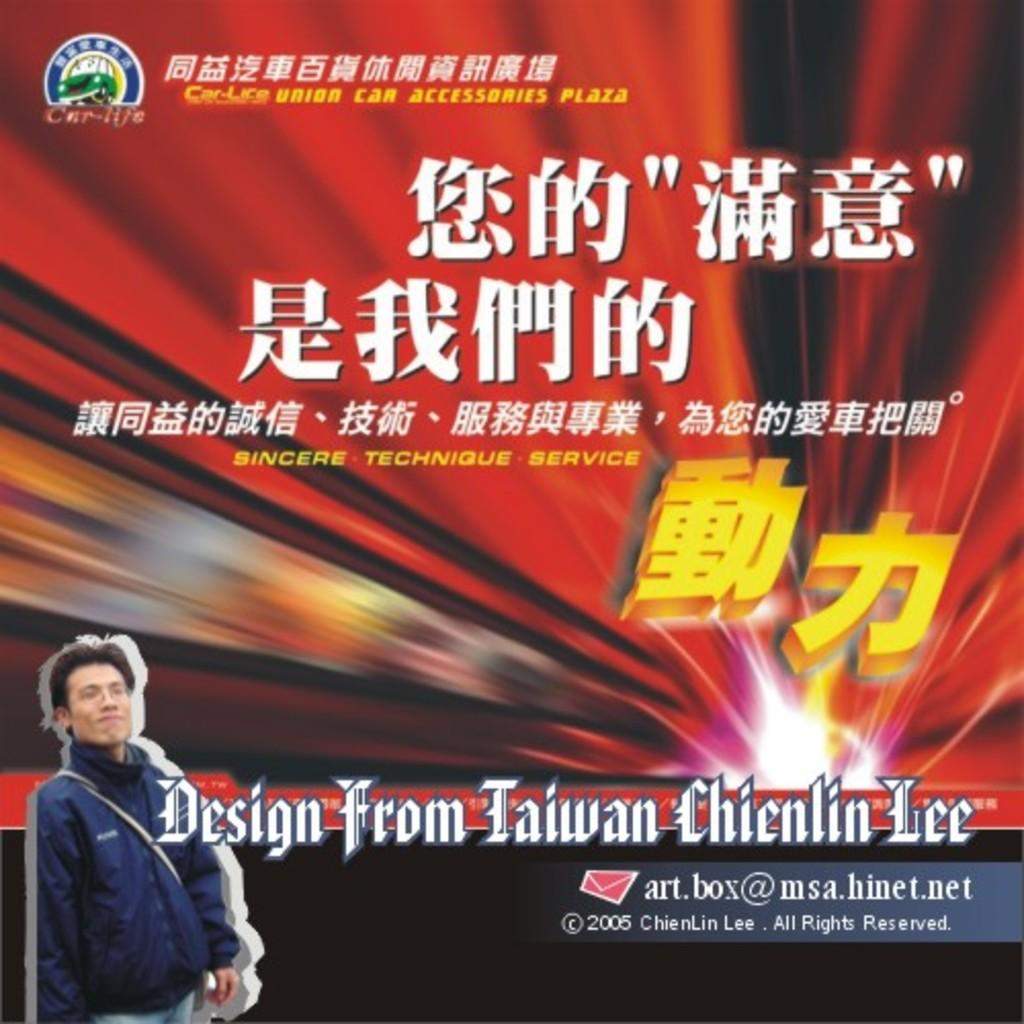Where is the man located in the image? The man is in the bottom left corner of the image. What is the man wearing on his face? The man is wearing spectacles. What type of clothing is the man wearing on his upper body? The man is wearing a jacket. What is the man carrying in the image? The man has a bag. What type of pants is the man wearing? The man is wearing jeans. What can be seen on the wall in the image? There is a poster in the image. What is written or depicted on the poster? Something is written on the poster. What type of metal is the man's chin made of in the image? The man's chin is not made of metal; it is a natural part of his face. 